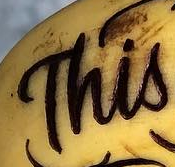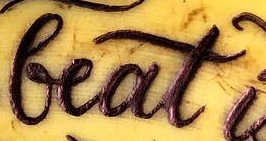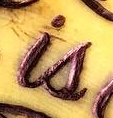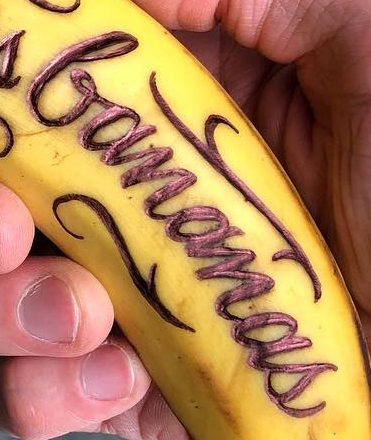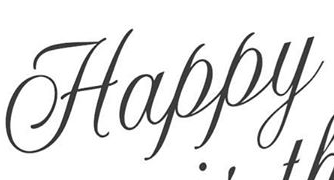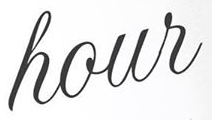What text appears in these images from left to right, separated by a semicolon? This; beat; is; bananas; Happy; hour 